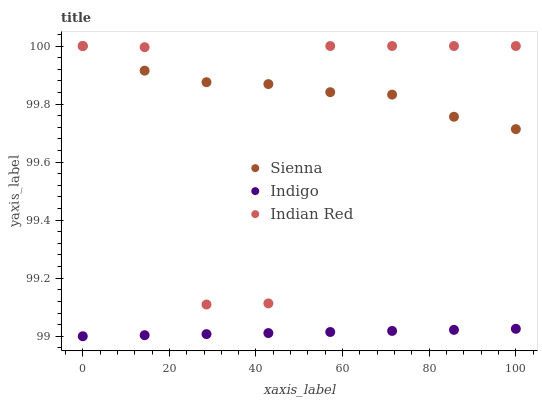Does Indigo have the minimum area under the curve?
Answer yes or no. Yes. Does Sienna have the maximum area under the curve?
Answer yes or no. Yes. Does Indian Red have the minimum area under the curve?
Answer yes or no. No. Does Indian Red have the maximum area under the curve?
Answer yes or no. No. Is Indigo the smoothest?
Answer yes or no. Yes. Is Indian Red the roughest?
Answer yes or no. Yes. Is Indian Red the smoothest?
Answer yes or no. No. Is Indigo the roughest?
Answer yes or no. No. Does Indigo have the lowest value?
Answer yes or no. Yes. Does Indian Red have the lowest value?
Answer yes or no. No. Does Indian Red have the highest value?
Answer yes or no. Yes. Does Indigo have the highest value?
Answer yes or no. No. Is Indigo less than Indian Red?
Answer yes or no. Yes. Is Sienna greater than Indigo?
Answer yes or no. Yes. Does Sienna intersect Indian Red?
Answer yes or no. Yes. Is Sienna less than Indian Red?
Answer yes or no. No. Is Sienna greater than Indian Red?
Answer yes or no. No. Does Indigo intersect Indian Red?
Answer yes or no. No. 